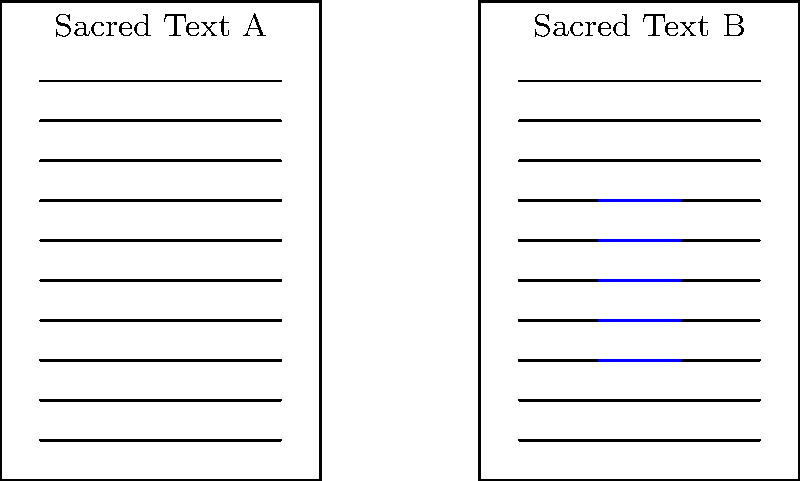Analyze the layout of the two sacred texts shown above. What is the most significant structural difference between Sacred Text A and Sacred Text B, and how might this difference impact the reader's engagement with the text? To answer this question, let's analyze the layouts step-by-step:

1. Sacred Text A:
   - Continuous lines of text from top to bottom
   - No visible breaks or decorative elements
   - Uniform structure throughout the page

2. Sacred Text B:
   - Continuous lines of text at the top and bottom
   - A distinct break in the middle with shorter lines on either side
   - A decorative element (shown in blue) in the center

3. The most significant structural difference:
   - Sacred Text B has a central break with a decorative element, while Sacred Text A has a continuous layout.

4. Impact on reader engagement:
   - The central break in Sacred Text B creates a visual focal point, potentially emphasizing a key passage or concept.
   - It may serve as a natural pause for reflection or meditation.
   - The decorative element could have symbolic or aesthetic significance.
   - Sacred Text A's continuous layout encourages uninterrupted reading and may emphasize the text's unity.

5. Scholarly interpretation:
   - The different layouts might reflect distinct religious traditions or textual purposes.
   - Sacred Text B's layout could indicate a more ritualistic or contemplative approach to reading.
   - Sacred Text A's layout might prioritize narrative continuity or logical flow.

The most significant structural difference is the central break with a decorative element in Sacred Text B, which is likely to impact reader engagement by creating a visual emphasis and potential pause for reflection, in contrast to the continuous flow of Sacred Text A.
Answer: Central break with decorative element in Sacred Text B, creating visual emphasis and reflective pause. 